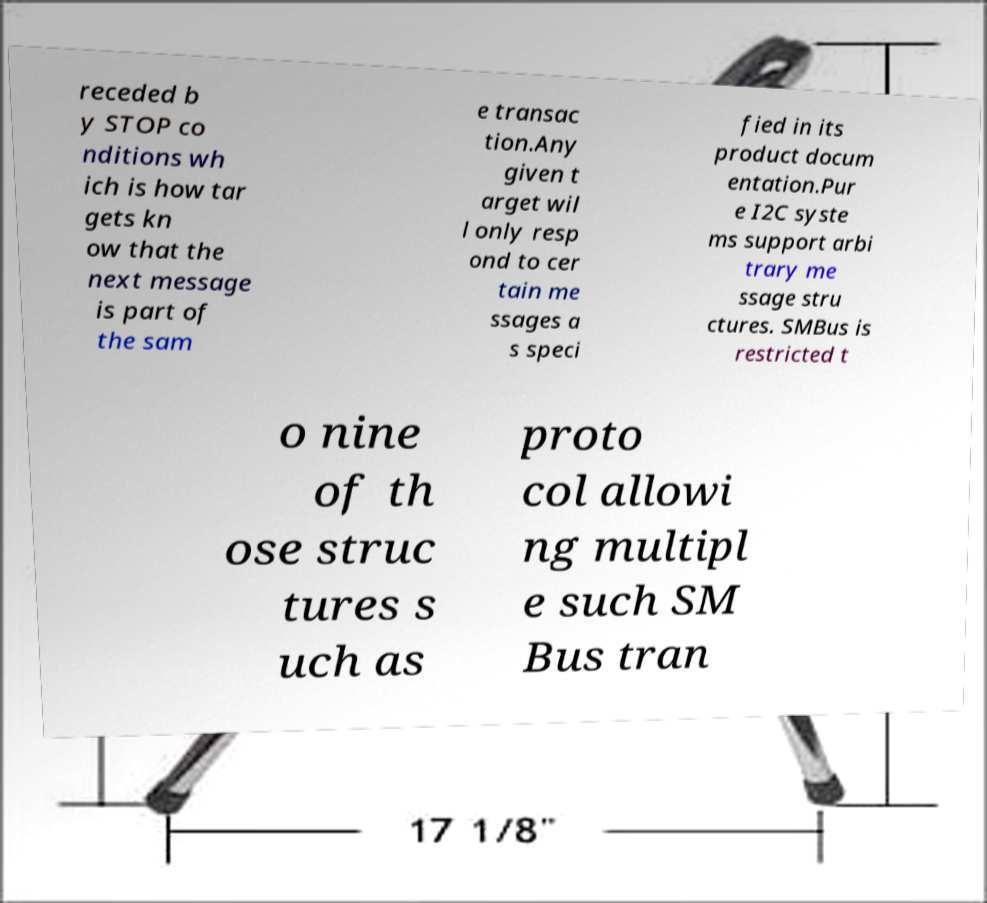I need the written content from this picture converted into text. Can you do that? receded b y STOP co nditions wh ich is how tar gets kn ow that the next message is part of the sam e transac tion.Any given t arget wil l only resp ond to cer tain me ssages a s speci fied in its product docum entation.Pur e I2C syste ms support arbi trary me ssage stru ctures. SMBus is restricted t o nine of th ose struc tures s uch as proto col allowi ng multipl e such SM Bus tran 